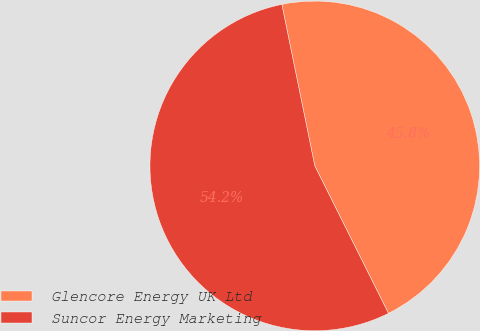<chart> <loc_0><loc_0><loc_500><loc_500><pie_chart><fcel>Glencore Energy UK Ltd<fcel>Suncor Energy Marketing<nl><fcel>45.83%<fcel>54.17%<nl></chart> 